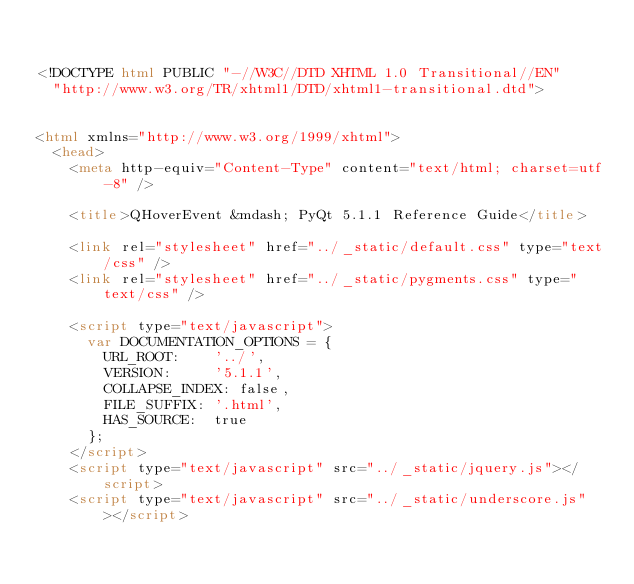<code> <loc_0><loc_0><loc_500><loc_500><_HTML_>

<!DOCTYPE html PUBLIC "-//W3C//DTD XHTML 1.0 Transitional//EN"
  "http://www.w3.org/TR/xhtml1/DTD/xhtml1-transitional.dtd">


<html xmlns="http://www.w3.org/1999/xhtml">
  <head>
    <meta http-equiv="Content-Type" content="text/html; charset=utf-8" />
    
    <title>QHoverEvent &mdash; PyQt 5.1.1 Reference Guide</title>
    
    <link rel="stylesheet" href="../_static/default.css" type="text/css" />
    <link rel="stylesheet" href="../_static/pygments.css" type="text/css" />
    
    <script type="text/javascript">
      var DOCUMENTATION_OPTIONS = {
        URL_ROOT:    '../',
        VERSION:     '5.1.1',
        COLLAPSE_INDEX: false,
        FILE_SUFFIX: '.html',
        HAS_SOURCE:  true
      };
    </script>
    <script type="text/javascript" src="../_static/jquery.js"></script>
    <script type="text/javascript" src="../_static/underscore.js"></script></code> 